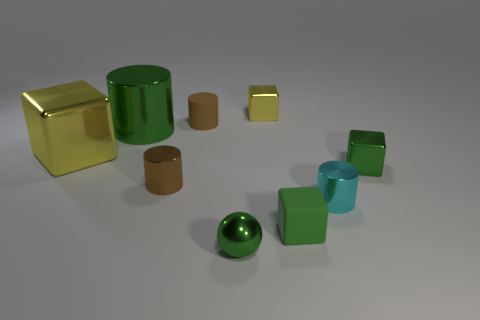Are there fewer tiny yellow things that are behind the large green metallic cylinder than large things that are behind the small brown shiny object?
Make the answer very short. Yes. How many other things are the same shape as the big yellow thing?
Your answer should be very brief. 3. How big is the green thing on the right side of the tiny cyan thing that is in front of the matte thing that is left of the shiny ball?
Ensure brevity in your answer.  Small. What number of purple things are cubes or large cubes?
Provide a succinct answer. 0. The tiny green metallic thing right of the small green block in front of the cyan cylinder is what shape?
Your answer should be very brief. Cube. Is the size of the yellow metallic thing that is to the left of the small yellow thing the same as the metal cylinder that is to the right of the small yellow metallic object?
Your response must be concise. No. Are there any cyan things made of the same material as the tiny yellow object?
Your answer should be very brief. Yes. What is the size of the metal block that is the same color as the tiny metal sphere?
Make the answer very short. Small. Is there a brown rubber cylinder that is in front of the small metallic ball that is in front of the small shiny thing that is on the left side of the tiny brown matte object?
Your response must be concise. No. Are there any green blocks to the left of the large yellow object?
Your answer should be very brief. No. 